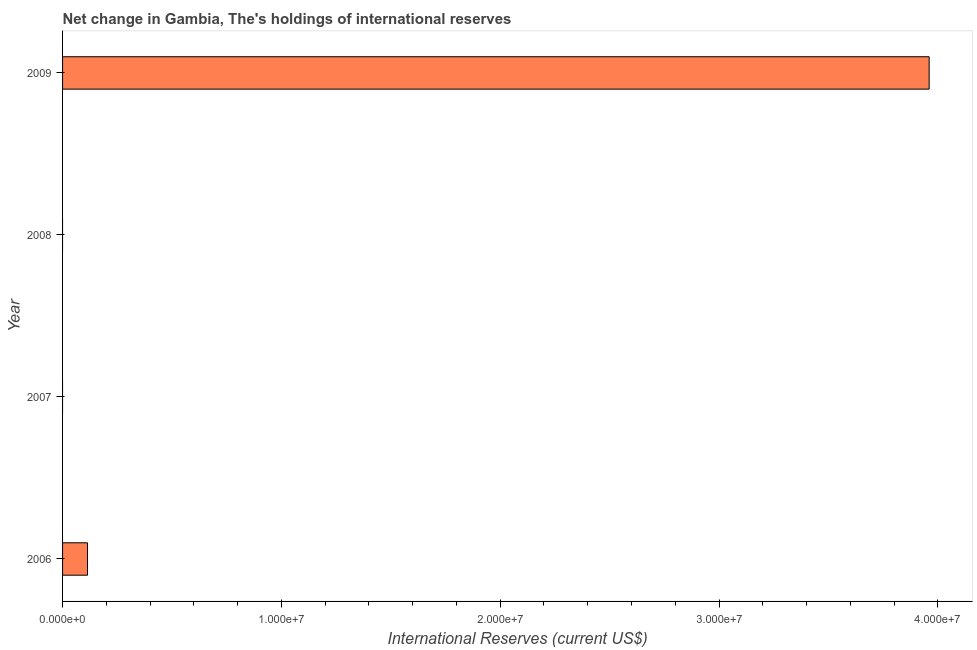Does the graph contain grids?
Keep it short and to the point. No. What is the title of the graph?
Give a very brief answer. Net change in Gambia, The's holdings of international reserves. What is the label or title of the X-axis?
Offer a very short reply. International Reserves (current US$). What is the reserves and related items in 2008?
Your response must be concise. 0. Across all years, what is the maximum reserves and related items?
Your answer should be very brief. 3.96e+07. What is the sum of the reserves and related items?
Provide a succinct answer. 4.07e+07. What is the difference between the reserves and related items in 2006 and 2009?
Keep it short and to the point. -3.85e+07. What is the average reserves and related items per year?
Make the answer very short. 1.02e+07. What is the median reserves and related items?
Provide a succinct answer. 5.70e+05. In how many years, is the reserves and related items greater than 22000000 US$?
Your answer should be very brief. 1. What is the ratio of the reserves and related items in 2006 to that in 2009?
Your answer should be very brief. 0.03. Is the reserves and related items in 2006 less than that in 2009?
Provide a succinct answer. Yes. What is the difference between the highest and the lowest reserves and related items?
Keep it short and to the point. 3.96e+07. In how many years, is the reserves and related items greater than the average reserves and related items taken over all years?
Give a very brief answer. 1. Are all the bars in the graph horizontal?
Give a very brief answer. Yes. How many years are there in the graph?
Your response must be concise. 4. What is the International Reserves (current US$) of 2006?
Make the answer very short. 1.14e+06. What is the International Reserves (current US$) of 2008?
Your response must be concise. 0. What is the International Reserves (current US$) of 2009?
Keep it short and to the point. 3.96e+07. What is the difference between the International Reserves (current US$) in 2006 and 2009?
Ensure brevity in your answer.  -3.85e+07. What is the ratio of the International Reserves (current US$) in 2006 to that in 2009?
Your response must be concise. 0.03. 